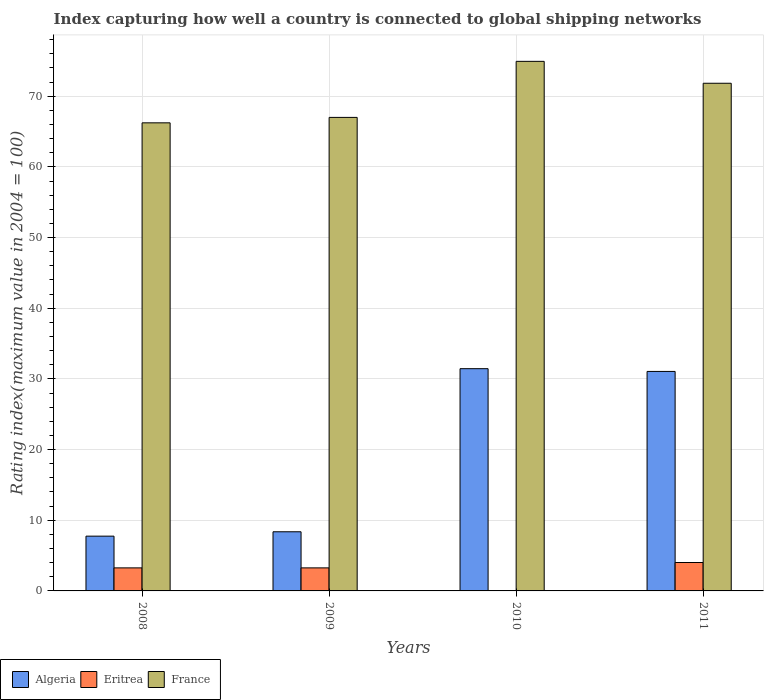Are the number of bars per tick equal to the number of legend labels?
Your response must be concise. Yes. Are the number of bars on each tick of the X-axis equal?
Give a very brief answer. Yes. How many bars are there on the 1st tick from the left?
Provide a short and direct response. 3. In how many cases, is the number of bars for a given year not equal to the number of legend labels?
Make the answer very short. 0. What is the rating index in Eritrea in 2009?
Make the answer very short. 3.26. Across all years, what is the maximum rating index in Algeria?
Your response must be concise. 31.45. In which year was the rating index in Eritrea minimum?
Offer a terse response. 2010. What is the total rating index in Algeria in the graph?
Give a very brief answer. 78.63. What is the difference between the rating index in Eritrea in 2008 and that in 2010?
Provide a short and direct response. 3.24. What is the difference between the rating index in Algeria in 2011 and the rating index in Eritrea in 2010?
Offer a very short reply. 31.04. What is the average rating index in Eritrea per year?
Offer a terse response. 2.64. In the year 2011, what is the difference between the rating index in France and rating index in Algeria?
Offer a very short reply. 40.78. In how many years, is the rating index in France greater than 44?
Offer a terse response. 4. What is the ratio of the rating index in Algeria in 2009 to that in 2011?
Your answer should be compact. 0.27. What is the difference between the highest and the second highest rating index in Algeria?
Make the answer very short. 0.39. What is the difference between the highest and the lowest rating index in Eritrea?
Make the answer very short. 4. What does the 2nd bar from the right in 2010 represents?
Keep it short and to the point. Eritrea. Is it the case that in every year, the sum of the rating index in France and rating index in Algeria is greater than the rating index in Eritrea?
Make the answer very short. Yes. Are all the bars in the graph horizontal?
Your response must be concise. No. How many years are there in the graph?
Your answer should be very brief. 4. Does the graph contain any zero values?
Your answer should be compact. No. How many legend labels are there?
Your response must be concise. 3. What is the title of the graph?
Provide a short and direct response. Index capturing how well a country is connected to global shipping networks. Does "Lesotho" appear as one of the legend labels in the graph?
Your answer should be very brief. No. What is the label or title of the X-axis?
Provide a short and direct response. Years. What is the label or title of the Y-axis?
Provide a short and direct response. Rating index(maximum value in 2004 = 100). What is the Rating index(maximum value in 2004 = 100) of Algeria in 2008?
Your response must be concise. 7.75. What is the Rating index(maximum value in 2004 = 100) in Eritrea in 2008?
Your answer should be very brief. 3.26. What is the Rating index(maximum value in 2004 = 100) in France in 2008?
Your response must be concise. 66.24. What is the Rating index(maximum value in 2004 = 100) of Algeria in 2009?
Provide a short and direct response. 8.37. What is the Rating index(maximum value in 2004 = 100) in Eritrea in 2009?
Provide a short and direct response. 3.26. What is the Rating index(maximum value in 2004 = 100) of France in 2009?
Offer a terse response. 67.01. What is the Rating index(maximum value in 2004 = 100) in Algeria in 2010?
Provide a short and direct response. 31.45. What is the Rating index(maximum value in 2004 = 100) in France in 2010?
Make the answer very short. 74.94. What is the Rating index(maximum value in 2004 = 100) of Algeria in 2011?
Offer a terse response. 31.06. What is the Rating index(maximum value in 2004 = 100) in Eritrea in 2011?
Ensure brevity in your answer.  4.02. What is the Rating index(maximum value in 2004 = 100) of France in 2011?
Provide a short and direct response. 71.84. Across all years, what is the maximum Rating index(maximum value in 2004 = 100) in Algeria?
Provide a succinct answer. 31.45. Across all years, what is the maximum Rating index(maximum value in 2004 = 100) of Eritrea?
Give a very brief answer. 4.02. Across all years, what is the maximum Rating index(maximum value in 2004 = 100) in France?
Give a very brief answer. 74.94. Across all years, what is the minimum Rating index(maximum value in 2004 = 100) of Algeria?
Provide a succinct answer. 7.75. Across all years, what is the minimum Rating index(maximum value in 2004 = 100) of France?
Provide a short and direct response. 66.24. What is the total Rating index(maximum value in 2004 = 100) in Algeria in the graph?
Offer a very short reply. 78.63. What is the total Rating index(maximum value in 2004 = 100) of Eritrea in the graph?
Your response must be concise. 10.56. What is the total Rating index(maximum value in 2004 = 100) of France in the graph?
Provide a succinct answer. 280.03. What is the difference between the Rating index(maximum value in 2004 = 100) of Algeria in 2008 and that in 2009?
Ensure brevity in your answer.  -0.62. What is the difference between the Rating index(maximum value in 2004 = 100) of France in 2008 and that in 2009?
Ensure brevity in your answer.  -0.77. What is the difference between the Rating index(maximum value in 2004 = 100) of Algeria in 2008 and that in 2010?
Make the answer very short. -23.7. What is the difference between the Rating index(maximum value in 2004 = 100) in Eritrea in 2008 and that in 2010?
Keep it short and to the point. 3.24. What is the difference between the Rating index(maximum value in 2004 = 100) in Algeria in 2008 and that in 2011?
Give a very brief answer. -23.31. What is the difference between the Rating index(maximum value in 2004 = 100) of Eritrea in 2008 and that in 2011?
Your answer should be compact. -0.76. What is the difference between the Rating index(maximum value in 2004 = 100) of Algeria in 2009 and that in 2010?
Make the answer very short. -23.08. What is the difference between the Rating index(maximum value in 2004 = 100) of Eritrea in 2009 and that in 2010?
Make the answer very short. 3.24. What is the difference between the Rating index(maximum value in 2004 = 100) in France in 2009 and that in 2010?
Offer a terse response. -7.93. What is the difference between the Rating index(maximum value in 2004 = 100) in Algeria in 2009 and that in 2011?
Your answer should be compact. -22.69. What is the difference between the Rating index(maximum value in 2004 = 100) of Eritrea in 2009 and that in 2011?
Your answer should be compact. -0.76. What is the difference between the Rating index(maximum value in 2004 = 100) of France in 2009 and that in 2011?
Your response must be concise. -4.83. What is the difference between the Rating index(maximum value in 2004 = 100) in Algeria in 2010 and that in 2011?
Your response must be concise. 0.39. What is the difference between the Rating index(maximum value in 2004 = 100) in Eritrea in 2010 and that in 2011?
Ensure brevity in your answer.  -4. What is the difference between the Rating index(maximum value in 2004 = 100) in France in 2010 and that in 2011?
Make the answer very short. 3.1. What is the difference between the Rating index(maximum value in 2004 = 100) of Algeria in 2008 and the Rating index(maximum value in 2004 = 100) of Eritrea in 2009?
Give a very brief answer. 4.49. What is the difference between the Rating index(maximum value in 2004 = 100) of Algeria in 2008 and the Rating index(maximum value in 2004 = 100) of France in 2009?
Your answer should be very brief. -59.26. What is the difference between the Rating index(maximum value in 2004 = 100) of Eritrea in 2008 and the Rating index(maximum value in 2004 = 100) of France in 2009?
Ensure brevity in your answer.  -63.75. What is the difference between the Rating index(maximum value in 2004 = 100) in Algeria in 2008 and the Rating index(maximum value in 2004 = 100) in Eritrea in 2010?
Offer a very short reply. 7.73. What is the difference between the Rating index(maximum value in 2004 = 100) of Algeria in 2008 and the Rating index(maximum value in 2004 = 100) of France in 2010?
Your answer should be compact. -67.19. What is the difference between the Rating index(maximum value in 2004 = 100) of Eritrea in 2008 and the Rating index(maximum value in 2004 = 100) of France in 2010?
Your answer should be compact. -71.68. What is the difference between the Rating index(maximum value in 2004 = 100) in Algeria in 2008 and the Rating index(maximum value in 2004 = 100) in Eritrea in 2011?
Your response must be concise. 3.73. What is the difference between the Rating index(maximum value in 2004 = 100) of Algeria in 2008 and the Rating index(maximum value in 2004 = 100) of France in 2011?
Offer a very short reply. -64.09. What is the difference between the Rating index(maximum value in 2004 = 100) of Eritrea in 2008 and the Rating index(maximum value in 2004 = 100) of France in 2011?
Your answer should be compact. -68.58. What is the difference between the Rating index(maximum value in 2004 = 100) in Algeria in 2009 and the Rating index(maximum value in 2004 = 100) in Eritrea in 2010?
Ensure brevity in your answer.  8.35. What is the difference between the Rating index(maximum value in 2004 = 100) of Algeria in 2009 and the Rating index(maximum value in 2004 = 100) of France in 2010?
Make the answer very short. -66.57. What is the difference between the Rating index(maximum value in 2004 = 100) in Eritrea in 2009 and the Rating index(maximum value in 2004 = 100) in France in 2010?
Provide a succinct answer. -71.68. What is the difference between the Rating index(maximum value in 2004 = 100) in Algeria in 2009 and the Rating index(maximum value in 2004 = 100) in Eritrea in 2011?
Your answer should be very brief. 4.35. What is the difference between the Rating index(maximum value in 2004 = 100) in Algeria in 2009 and the Rating index(maximum value in 2004 = 100) in France in 2011?
Make the answer very short. -63.47. What is the difference between the Rating index(maximum value in 2004 = 100) in Eritrea in 2009 and the Rating index(maximum value in 2004 = 100) in France in 2011?
Your answer should be compact. -68.58. What is the difference between the Rating index(maximum value in 2004 = 100) of Algeria in 2010 and the Rating index(maximum value in 2004 = 100) of Eritrea in 2011?
Provide a short and direct response. 27.43. What is the difference between the Rating index(maximum value in 2004 = 100) in Algeria in 2010 and the Rating index(maximum value in 2004 = 100) in France in 2011?
Ensure brevity in your answer.  -40.39. What is the difference between the Rating index(maximum value in 2004 = 100) in Eritrea in 2010 and the Rating index(maximum value in 2004 = 100) in France in 2011?
Your answer should be compact. -71.82. What is the average Rating index(maximum value in 2004 = 100) in Algeria per year?
Offer a terse response. 19.66. What is the average Rating index(maximum value in 2004 = 100) in Eritrea per year?
Provide a succinct answer. 2.64. What is the average Rating index(maximum value in 2004 = 100) of France per year?
Offer a terse response. 70.01. In the year 2008, what is the difference between the Rating index(maximum value in 2004 = 100) of Algeria and Rating index(maximum value in 2004 = 100) of Eritrea?
Your answer should be very brief. 4.49. In the year 2008, what is the difference between the Rating index(maximum value in 2004 = 100) in Algeria and Rating index(maximum value in 2004 = 100) in France?
Offer a terse response. -58.49. In the year 2008, what is the difference between the Rating index(maximum value in 2004 = 100) in Eritrea and Rating index(maximum value in 2004 = 100) in France?
Your answer should be compact. -62.98. In the year 2009, what is the difference between the Rating index(maximum value in 2004 = 100) in Algeria and Rating index(maximum value in 2004 = 100) in Eritrea?
Offer a terse response. 5.11. In the year 2009, what is the difference between the Rating index(maximum value in 2004 = 100) of Algeria and Rating index(maximum value in 2004 = 100) of France?
Your answer should be compact. -58.64. In the year 2009, what is the difference between the Rating index(maximum value in 2004 = 100) in Eritrea and Rating index(maximum value in 2004 = 100) in France?
Your answer should be very brief. -63.75. In the year 2010, what is the difference between the Rating index(maximum value in 2004 = 100) of Algeria and Rating index(maximum value in 2004 = 100) of Eritrea?
Your answer should be compact. 31.43. In the year 2010, what is the difference between the Rating index(maximum value in 2004 = 100) in Algeria and Rating index(maximum value in 2004 = 100) in France?
Your answer should be very brief. -43.49. In the year 2010, what is the difference between the Rating index(maximum value in 2004 = 100) of Eritrea and Rating index(maximum value in 2004 = 100) of France?
Your answer should be very brief. -74.92. In the year 2011, what is the difference between the Rating index(maximum value in 2004 = 100) in Algeria and Rating index(maximum value in 2004 = 100) in Eritrea?
Your response must be concise. 27.04. In the year 2011, what is the difference between the Rating index(maximum value in 2004 = 100) of Algeria and Rating index(maximum value in 2004 = 100) of France?
Offer a terse response. -40.78. In the year 2011, what is the difference between the Rating index(maximum value in 2004 = 100) in Eritrea and Rating index(maximum value in 2004 = 100) in France?
Your response must be concise. -67.82. What is the ratio of the Rating index(maximum value in 2004 = 100) of Algeria in 2008 to that in 2009?
Your answer should be very brief. 0.93. What is the ratio of the Rating index(maximum value in 2004 = 100) in Algeria in 2008 to that in 2010?
Your response must be concise. 0.25. What is the ratio of the Rating index(maximum value in 2004 = 100) of Eritrea in 2008 to that in 2010?
Give a very brief answer. 163. What is the ratio of the Rating index(maximum value in 2004 = 100) of France in 2008 to that in 2010?
Ensure brevity in your answer.  0.88. What is the ratio of the Rating index(maximum value in 2004 = 100) in Algeria in 2008 to that in 2011?
Ensure brevity in your answer.  0.25. What is the ratio of the Rating index(maximum value in 2004 = 100) of Eritrea in 2008 to that in 2011?
Ensure brevity in your answer.  0.81. What is the ratio of the Rating index(maximum value in 2004 = 100) of France in 2008 to that in 2011?
Give a very brief answer. 0.92. What is the ratio of the Rating index(maximum value in 2004 = 100) in Algeria in 2009 to that in 2010?
Offer a terse response. 0.27. What is the ratio of the Rating index(maximum value in 2004 = 100) of Eritrea in 2009 to that in 2010?
Your answer should be compact. 163. What is the ratio of the Rating index(maximum value in 2004 = 100) of France in 2009 to that in 2010?
Your answer should be very brief. 0.89. What is the ratio of the Rating index(maximum value in 2004 = 100) of Algeria in 2009 to that in 2011?
Provide a succinct answer. 0.27. What is the ratio of the Rating index(maximum value in 2004 = 100) in Eritrea in 2009 to that in 2011?
Your answer should be very brief. 0.81. What is the ratio of the Rating index(maximum value in 2004 = 100) in France in 2009 to that in 2011?
Ensure brevity in your answer.  0.93. What is the ratio of the Rating index(maximum value in 2004 = 100) in Algeria in 2010 to that in 2011?
Your answer should be compact. 1.01. What is the ratio of the Rating index(maximum value in 2004 = 100) of Eritrea in 2010 to that in 2011?
Give a very brief answer. 0.01. What is the ratio of the Rating index(maximum value in 2004 = 100) in France in 2010 to that in 2011?
Ensure brevity in your answer.  1.04. What is the difference between the highest and the second highest Rating index(maximum value in 2004 = 100) of Algeria?
Offer a very short reply. 0.39. What is the difference between the highest and the second highest Rating index(maximum value in 2004 = 100) in Eritrea?
Give a very brief answer. 0.76. What is the difference between the highest and the lowest Rating index(maximum value in 2004 = 100) of Algeria?
Offer a terse response. 23.7. What is the difference between the highest and the lowest Rating index(maximum value in 2004 = 100) of France?
Give a very brief answer. 8.7. 